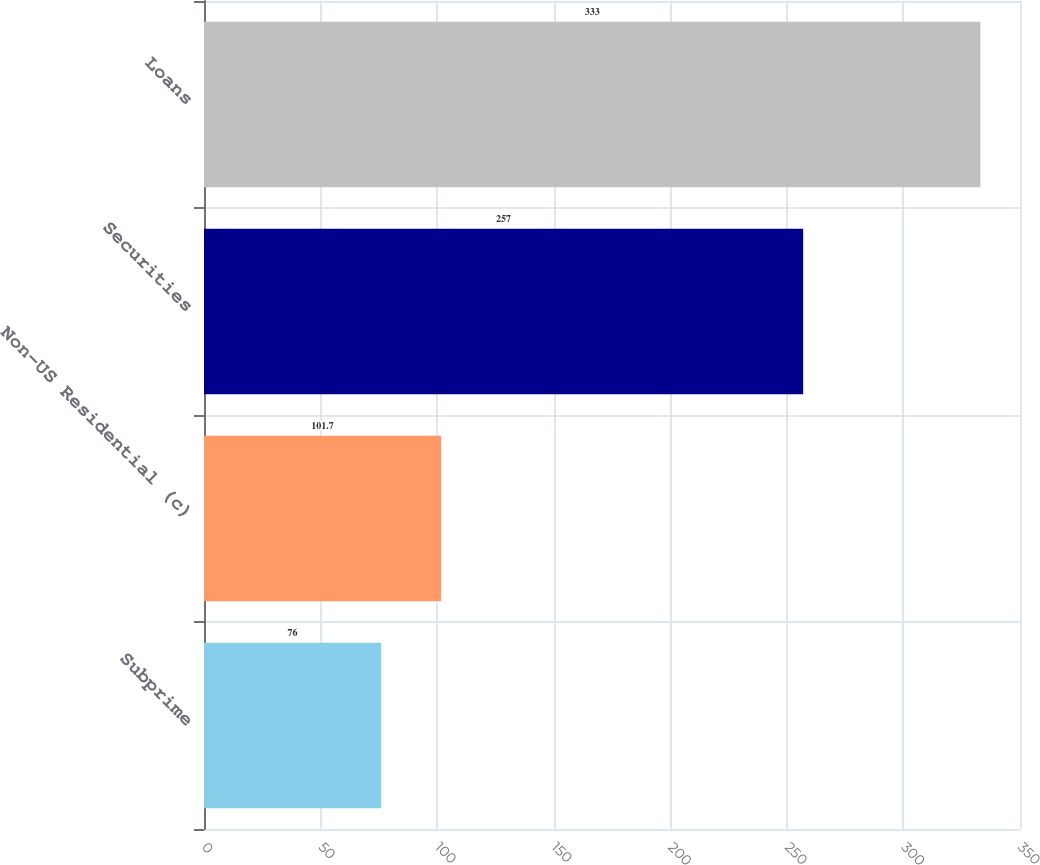Convert chart to OTSL. <chart><loc_0><loc_0><loc_500><loc_500><bar_chart><fcel>Subprime<fcel>Non-US Residential (c)<fcel>Securities<fcel>Loans<nl><fcel>76<fcel>101.7<fcel>257<fcel>333<nl></chart> 